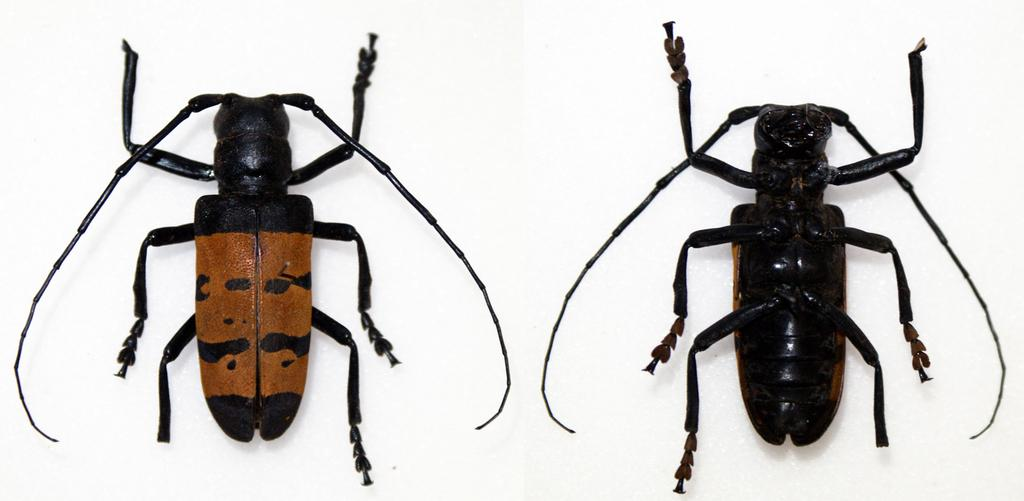What type of insects can be seen in the image? There are two insects in the image. What is the color of the background in the image? The background of the image is white in color. What type of eggs can be seen in the image? There are no eggs present in the image; it features two insects. Can you see any smoke coming from the insects in the image? There is no smoke present in the image. 